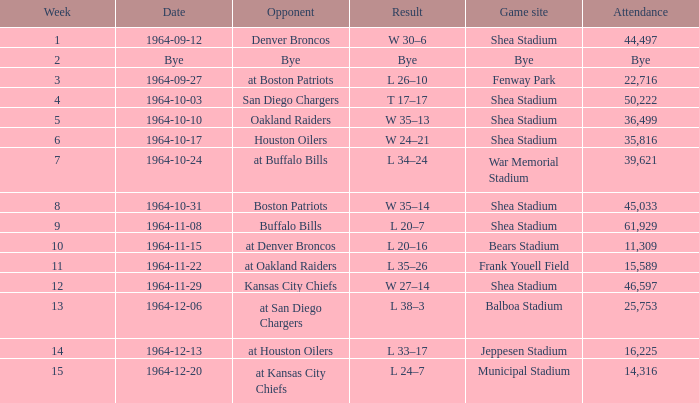What's the result of the game against Bye? Bye. 